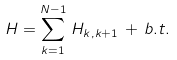Convert formula to latex. <formula><loc_0><loc_0><loc_500><loc_500>H = \sum _ { k = 1 } ^ { N - 1 } \, H _ { k , k + 1 } \, + \, b . t .</formula> 